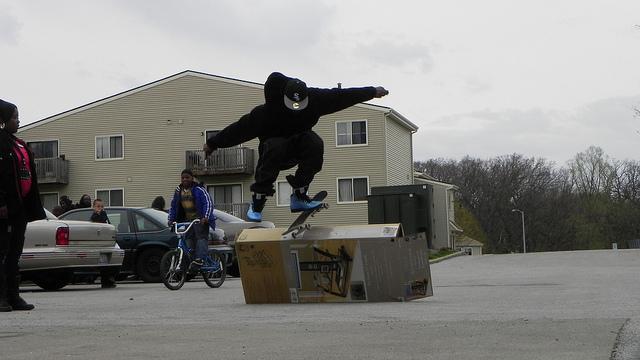How many people are there?
Give a very brief answer. 3. How many cars can you see?
Give a very brief answer. 2. 